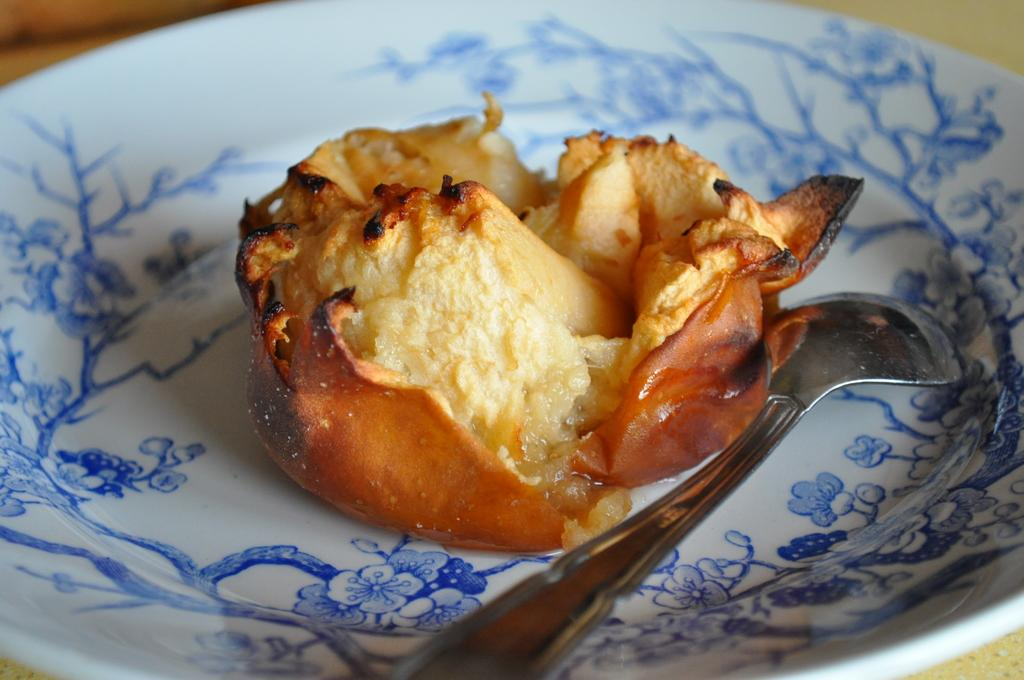What is on the plate that is visible in the image? The plate contains edible items. What utensil is present in the image? There is a spoon in the image. Where are the plate and spoon located in the image? The plate and spoon are placed on a table. What type of nose can be seen on the plate in the image? There is no nose present on the plate in the image; it contains edible items. 